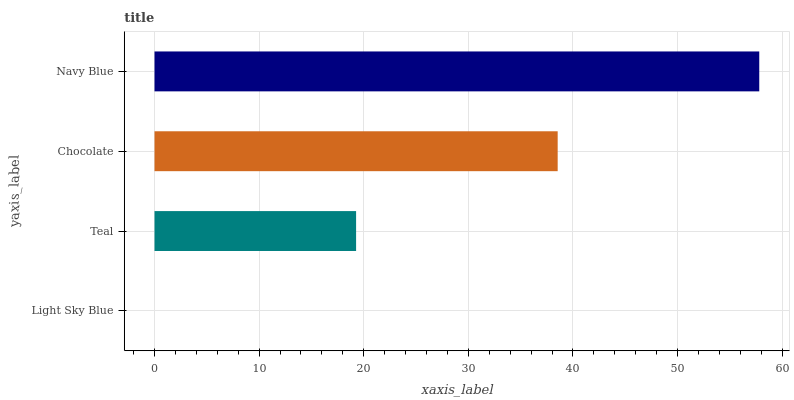Is Light Sky Blue the minimum?
Answer yes or no. Yes. Is Navy Blue the maximum?
Answer yes or no. Yes. Is Teal the minimum?
Answer yes or no. No. Is Teal the maximum?
Answer yes or no. No. Is Teal greater than Light Sky Blue?
Answer yes or no. Yes. Is Light Sky Blue less than Teal?
Answer yes or no. Yes. Is Light Sky Blue greater than Teal?
Answer yes or no. No. Is Teal less than Light Sky Blue?
Answer yes or no. No. Is Chocolate the high median?
Answer yes or no. Yes. Is Teal the low median?
Answer yes or no. Yes. Is Teal the high median?
Answer yes or no. No. Is Navy Blue the low median?
Answer yes or no. No. 